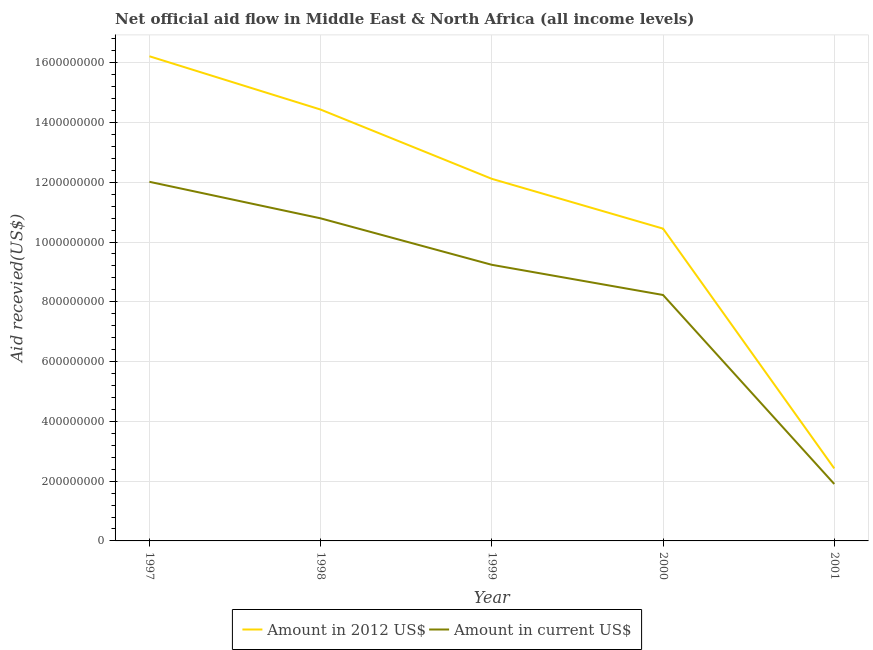What is the amount of aid received(expressed in 2012 us$) in 1997?
Keep it short and to the point. 1.62e+09. Across all years, what is the maximum amount of aid received(expressed in 2012 us$)?
Your response must be concise. 1.62e+09. Across all years, what is the minimum amount of aid received(expressed in 2012 us$)?
Your response must be concise. 2.43e+08. In which year was the amount of aid received(expressed in 2012 us$) maximum?
Your response must be concise. 1997. In which year was the amount of aid received(expressed in us$) minimum?
Keep it short and to the point. 2001. What is the total amount of aid received(expressed in us$) in the graph?
Provide a succinct answer. 4.22e+09. What is the difference between the amount of aid received(expressed in 2012 us$) in 1999 and that in 2000?
Provide a short and direct response. 1.67e+08. What is the difference between the amount of aid received(expressed in us$) in 1998 and the amount of aid received(expressed in 2012 us$) in 2001?
Ensure brevity in your answer.  8.37e+08. What is the average amount of aid received(expressed in us$) per year?
Offer a terse response. 8.44e+08. In the year 1998, what is the difference between the amount of aid received(expressed in 2012 us$) and amount of aid received(expressed in us$)?
Ensure brevity in your answer.  3.64e+08. What is the ratio of the amount of aid received(expressed in us$) in 1998 to that in 2000?
Keep it short and to the point. 1.31. What is the difference between the highest and the second highest amount of aid received(expressed in 2012 us$)?
Your answer should be compact. 1.78e+08. What is the difference between the highest and the lowest amount of aid received(expressed in 2012 us$)?
Give a very brief answer. 1.38e+09. In how many years, is the amount of aid received(expressed in us$) greater than the average amount of aid received(expressed in us$) taken over all years?
Make the answer very short. 3. Is the amount of aid received(expressed in 2012 us$) strictly greater than the amount of aid received(expressed in us$) over the years?
Keep it short and to the point. Yes. Does the graph contain any zero values?
Your response must be concise. No. Where does the legend appear in the graph?
Your answer should be very brief. Bottom center. How are the legend labels stacked?
Provide a succinct answer. Horizontal. What is the title of the graph?
Provide a succinct answer. Net official aid flow in Middle East & North Africa (all income levels). What is the label or title of the Y-axis?
Your answer should be compact. Aid recevied(US$). What is the Aid recevied(US$) in Amount in 2012 US$ in 1997?
Ensure brevity in your answer.  1.62e+09. What is the Aid recevied(US$) in Amount in current US$ in 1997?
Provide a short and direct response. 1.20e+09. What is the Aid recevied(US$) of Amount in 2012 US$ in 1998?
Make the answer very short. 1.44e+09. What is the Aid recevied(US$) of Amount in current US$ in 1998?
Your answer should be very brief. 1.08e+09. What is the Aid recevied(US$) in Amount in 2012 US$ in 1999?
Your response must be concise. 1.21e+09. What is the Aid recevied(US$) of Amount in current US$ in 1999?
Offer a very short reply. 9.24e+08. What is the Aid recevied(US$) in Amount in 2012 US$ in 2000?
Provide a succinct answer. 1.04e+09. What is the Aid recevied(US$) of Amount in current US$ in 2000?
Offer a very short reply. 8.23e+08. What is the Aid recevied(US$) of Amount in 2012 US$ in 2001?
Your answer should be compact. 2.43e+08. What is the Aid recevied(US$) in Amount in current US$ in 2001?
Provide a succinct answer. 1.90e+08. Across all years, what is the maximum Aid recevied(US$) of Amount in 2012 US$?
Offer a very short reply. 1.62e+09. Across all years, what is the maximum Aid recevied(US$) of Amount in current US$?
Ensure brevity in your answer.  1.20e+09. Across all years, what is the minimum Aid recevied(US$) of Amount in 2012 US$?
Your answer should be compact. 2.43e+08. Across all years, what is the minimum Aid recevied(US$) in Amount in current US$?
Offer a very short reply. 1.90e+08. What is the total Aid recevied(US$) of Amount in 2012 US$ in the graph?
Provide a short and direct response. 5.56e+09. What is the total Aid recevied(US$) of Amount in current US$ in the graph?
Make the answer very short. 4.22e+09. What is the difference between the Aid recevied(US$) in Amount in 2012 US$ in 1997 and that in 1998?
Make the answer very short. 1.78e+08. What is the difference between the Aid recevied(US$) in Amount in current US$ in 1997 and that in 1998?
Your answer should be very brief. 1.22e+08. What is the difference between the Aid recevied(US$) in Amount in 2012 US$ in 1997 and that in 1999?
Ensure brevity in your answer.  4.10e+08. What is the difference between the Aid recevied(US$) in Amount in current US$ in 1997 and that in 1999?
Provide a succinct answer. 2.78e+08. What is the difference between the Aid recevied(US$) of Amount in 2012 US$ in 1997 and that in 2000?
Your answer should be very brief. 5.77e+08. What is the difference between the Aid recevied(US$) in Amount in current US$ in 1997 and that in 2000?
Your response must be concise. 3.79e+08. What is the difference between the Aid recevied(US$) of Amount in 2012 US$ in 1997 and that in 2001?
Your response must be concise. 1.38e+09. What is the difference between the Aid recevied(US$) in Amount in current US$ in 1997 and that in 2001?
Give a very brief answer. 1.01e+09. What is the difference between the Aid recevied(US$) in Amount in 2012 US$ in 1998 and that in 1999?
Keep it short and to the point. 2.32e+08. What is the difference between the Aid recevied(US$) in Amount in current US$ in 1998 and that in 1999?
Your answer should be compact. 1.55e+08. What is the difference between the Aid recevied(US$) of Amount in 2012 US$ in 1998 and that in 2000?
Offer a very short reply. 3.98e+08. What is the difference between the Aid recevied(US$) in Amount in current US$ in 1998 and that in 2000?
Ensure brevity in your answer.  2.56e+08. What is the difference between the Aid recevied(US$) in Amount in 2012 US$ in 1998 and that in 2001?
Keep it short and to the point. 1.20e+09. What is the difference between the Aid recevied(US$) of Amount in current US$ in 1998 and that in 2001?
Give a very brief answer. 8.89e+08. What is the difference between the Aid recevied(US$) in Amount in 2012 US$ in 1999 and that in 2000?
Your response must be concise. 1.67e+08. What is the difference between the Aid recevied(US$) in Amount in current US$ in 1999 and that in 2000?
Keep it short and to the point. 1.01e+08. What is the difference between the Aid recevied(US$) of Amount in 2012 US$ in 1999 and that in 2001?
Your answer should be very brief. 9.69e+08. What is the difference between the Aid recevied(US$) of Amount in current US$ in 1999 and that in 2001?
Ensure brevity in your answer.  7.33e+08. What is the difference between the Aid recevied(US$) of Amount in 2012 US$ in 2000 and that in 2001?
Provide a short and direct response. 8.02e+08. What is the difference between the Aid recevied(US$) of Amount in current US$ in 2000 and that in 2001?
Give a very brief answer. 6.32e+08. What is the difference between the Aid recevied(US$) in Amount in 2012 US$ in 1997 and the Aid recevied(US$) in Amount in current US$ in 1998?
Your answer should be very brief. 5.42e+08. What is the difference between the Aid recevied(US$) in Amount in 2012 US$ in 1997 and the Aid recevied(US$) in Amount in current US$ in 1999?
Your answer should be compact. 6.98e+08. What is the difference between the Aid recevied(US$) in Amount in 2012 US$ in 1997 and the Aid recevied(US$) in Amount in current US$ in 2000?
Keep it short and to the point. 7.99e+08. What is the difference between the Aid recevied(US$) in Amount in 2012 US$ in 1997 and the Aid recevied(US$) in Amount in current US$ in 2001?
Your answer should be very brief. 1.43e+09. What is the difference between the Aid recevied(US$) of Amount in 2012 US$ in 1998 and the Aid recevied(US$) of Amount in current US$ in 1999?
Your answer should be compact. 5.19e+08. What is the difference between the Aid recevied(US$) of Amount in 2012 US$ in 1998 and the Aid recevied(US$) of Amount in current US$ in 2000?
Give a very brief answer. 6.20e+08. What is the difference between the Aid recevied(US$) in Amount in 2012 US$ in 1998 and the Aid recevied(US$) in Amount in current US$ in 2001?
Your answer should be very brief. 1.25e+09. What is the difference between the Aid recevied(US$) of Amount in 2012 US$ in 1999 and the Aid recevied(US$) of Amount in current US$ in 2000?
Make the answer very short. 3.89e+08. What is the difference between the Aid recevied(US$) of Amount in 2012 US$ in 1999 and the Aid recevied(US$) of Amount in current US$ in 2001?
Keep it short and to the point. 1.02e+09. What is the difference between the Aid recevied(US$) of Amount in 2012 US$ in 2000 and the Aid recevied(US$) of Amount in current US$ in 2001?
Your answer should be very brief. 8.54e+08. What is the average Aid recevied(US$) in Amount in 2012 US$ per year?
Your response must be concise. 1.11e+09. What is the average Aid recevied(US$) of Amount in current US$ per year?
Your answer should be very brief. 8.44e+08. In the year 1997, what is the difference between the Aid recevied(US$) in Amount in 2012 US$ and Aid recevied(US$) in Amount in current US$?
Your answer should be very brief. 4.20e+08. In the year 1998, what is the difference between the Aid recevied(US$) in Amount in 2012 US$ and Aid recevied(US$) in Amount in current US$?
Your answer should be very brief. 3.64e+08. In the year 1999, what is the difference between the Aid recevied(US$) in Amount in 2012 US$ and Aid recevied(US$) in Amount in current US$?
Offer a very short reply. 2.88e+08. In the year 2000, what is the difference between the Aid recevied(US$) in Amount in 2012 US$ and Aid recevied(US$) in Amount in current US$?
Offer a terse response. 2.22e+08. In the year 2001, what is the difference between the Aid recevied(US$) of Amount in 2012 US$ and Aid recevied(US$) of Amount in current US$?
Your response must be concise. 5.21e+07. What is the ratio of the Aid recevied(US$) in Amount in 2012 US$ in 1997 to that in 1998?
Give a very brief answer. 1.12. What is the ratio of the Aid recevied(US$) of Amount in current US$ in 1997 to that in 1998?
Ensure brevity in your answer.  1.11. What is the ratio of the Aid recevied(US$) of Amount in 2012 US$ in 1997 to that in 1999?
Give a very brief answer. 1.34. What is the ratio of the Aid recevied(US$) in Amount in current US$ in 1997 to that in 1999?
Your answer should be very brief. 1.3. What is the ratio of the Aid recevied(US$) of Amount in 2012 US$ in 1997 to that in 2000?
Your response must be concise. 1.55. What is the ratio of the Aid recevied(US$) in Amount in current US$ in 1997 to that in 2000?
Provide a succinct answer. 1.46. What is the ratio of the Aid recevied(US$) of Amount in 2012 US$ in 1997 to that in 2001?
Your response must be concise. 6.69. What is the ratio of the Aid recevied(US$) of Amount in current US$ in 1997 to that in 2001?
Give a very brief answer. 6.31. What is the ratio of the Aid recevied(US$) in Amount in 2012 US$ in 1998 to that in 1999?
Your answer should be very brief. 1.19. What is the ratio of the Aid recevied(US$) of Amount in current US$ in 1998 to that in 1999?
Make the answer very short. 1.17. What is the ratio of the Aid recevied(US$) of Amount in 2012 US$ in 1998 to that in 2000?
Your answer should be compact. 1.38. What is the ratio of the Aid recevied(US$) in Amount in current US$ in 1998 to that in 2000?
Offer a terse response. 1.31. What is the ratio of the Aid recevied(US$) in Amount in 2012 US$ in 1998 to that in 2001?
Your answer should be compact. 5.95. What is the ratio of the Aid recevied(US$) in Amount in current US$ in 1998 to that in 2001?
Give a very brief answer. 5.67. What is the ratio of the Aid recevied(US$) in Amount in 2012 US$ in 1999 to that in 2000?
Offer a very short reply. 1.16. What is the ratio of the Aid recevied(US$) in Amount in current US$ in 1999 to that in 2000?
Your response must be concise. 1.12. What is the ratio of the Aid recevied(US$) of Amount in 2012 US$ in 1999 to that in 2001?
Your response must be concise. 4.99. What is the ratio of the Aid recevied(US$) in Amount in current US$ in 1999 to that in 2001?
Make the answer very short. 4.85. What is the ratio of the Aid recevied(US$) in Amount in 2012 US$ in 2000 to that in 2001?
Offer a terse response. 4.31. What is the ratio of the Aid recevied(US$) in Amount in current US$ in 2000 to that in 2001?
Your answer should be very brief. 4.32. What is the difference between the highest and the second highest Aid recevied(US$) in Amount in 2012 US$?
Provide a short and direct response. 1.78e+08. What is the difference between the highest and the second highest Aid recevied(US$) in Amount in current US$?
Give a very brief answer. 1.22e+08. What is the difference between the highest and the lowest Aid recevied(US$) in Amount in 2012 US$?
Make the answer very short. 1.38e+09. What is the difference between the highest and the lowest Aid recevied(US$) in Amount in current US$?
Make the answer very short. 1.01e+09. 